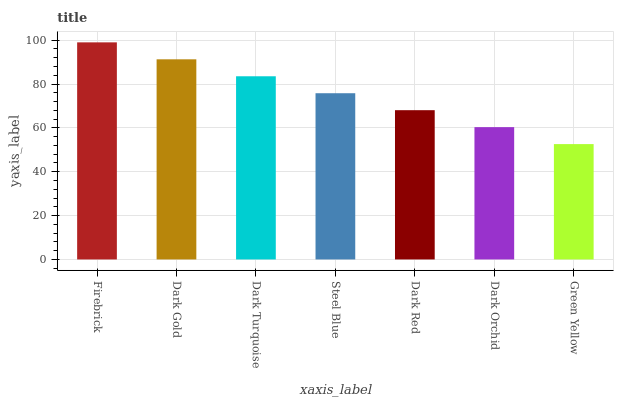Is Green Yellow the minimum?
Answer yes or no. Yes. Is Firebrick the maximum?
Answer yes or no. Yes. Is Dark Gold the minimum?
Answer yes or no. No. Is Dark Gold the maximum?
Answer yes or no. No. Is Firebrick greater than Dark Gold?
Answer yes or no. Yes. Is Dark Gold less than Firebrick?
Answer yes or no. Yes. Is Dark Gold greater than Firebrick?
Answer yes or no. No. Is Firebrick less than Dark Gold?
Answer yes or no. No. Is Steel Blue the high median?
Answer yes or no. Yes. Is Steel Blue the low median?
Answer yes or no. Yes. Is Green Yellow the high median?
Answer yes or no. No. Is Firebrick the low median?
Answer yes or no. No. 